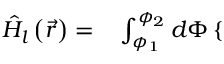Convert formula to latex. <formula><loc_0><loc_0><loc_500><loc_500>\begin{array} { r l } { \hat { H } _ { l } \left ( \vec { r } \right ) = } & \int _ { \phi _ { 1 } } ^ { \phi _ { 2 } } d \Phi \left \{ \begin{array} { l l } \end{array} } \end{array}</formula> 